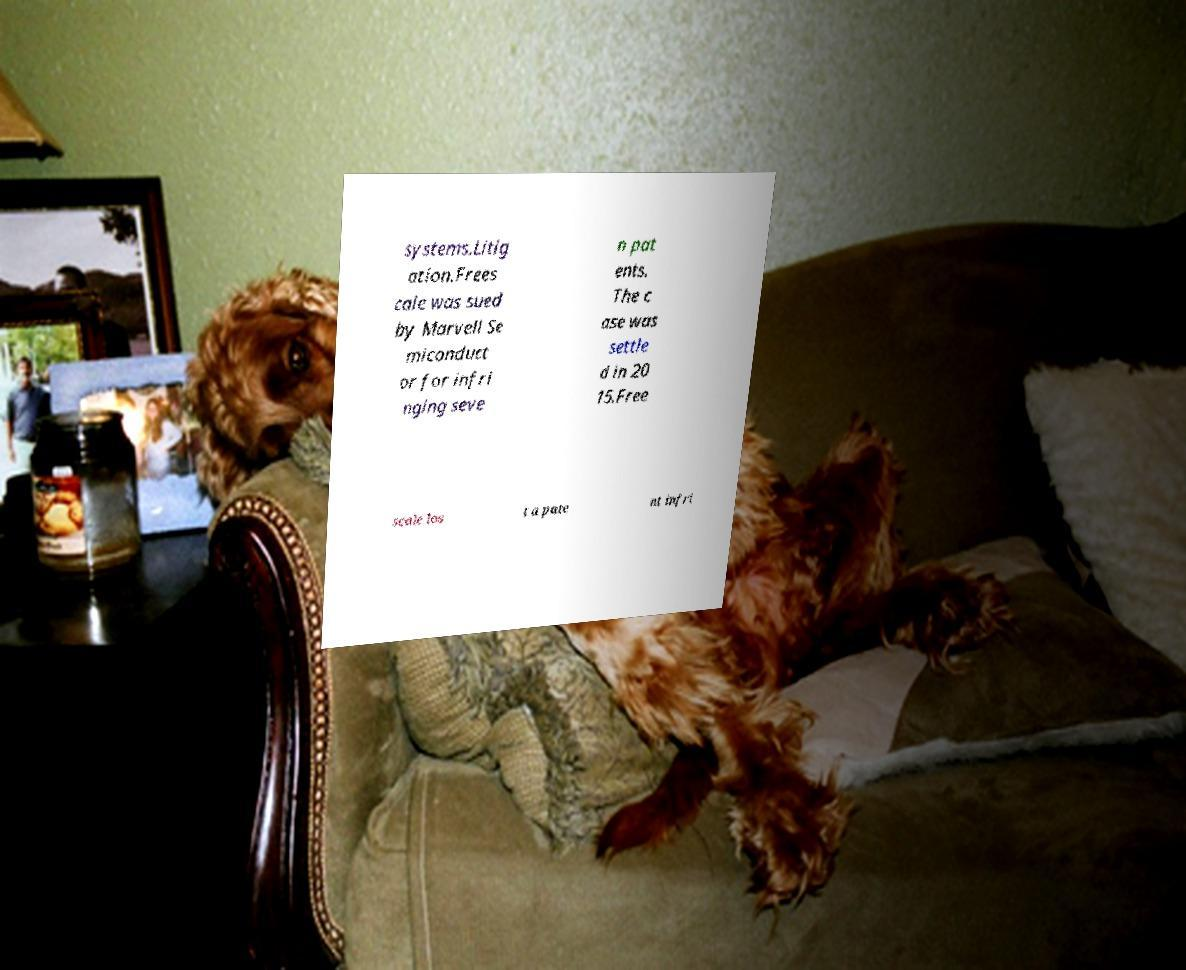Could you assist in decoding the text presented in this image and type it out clearly? systems.Litig ation.Frees cale was sued by Marvell Se miconduct or for infri nging seve n pat ents. The c ase was settle d in 20 15.Free scale los t a pate nt infri 